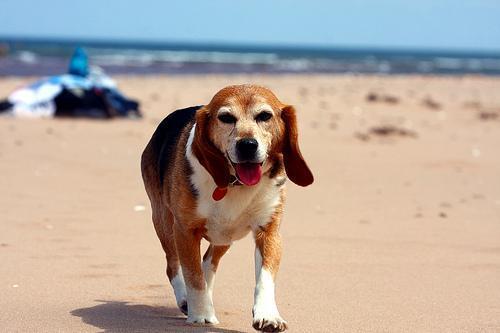How many dogs are visible in this photo?
Give a very brief answer. 1. 